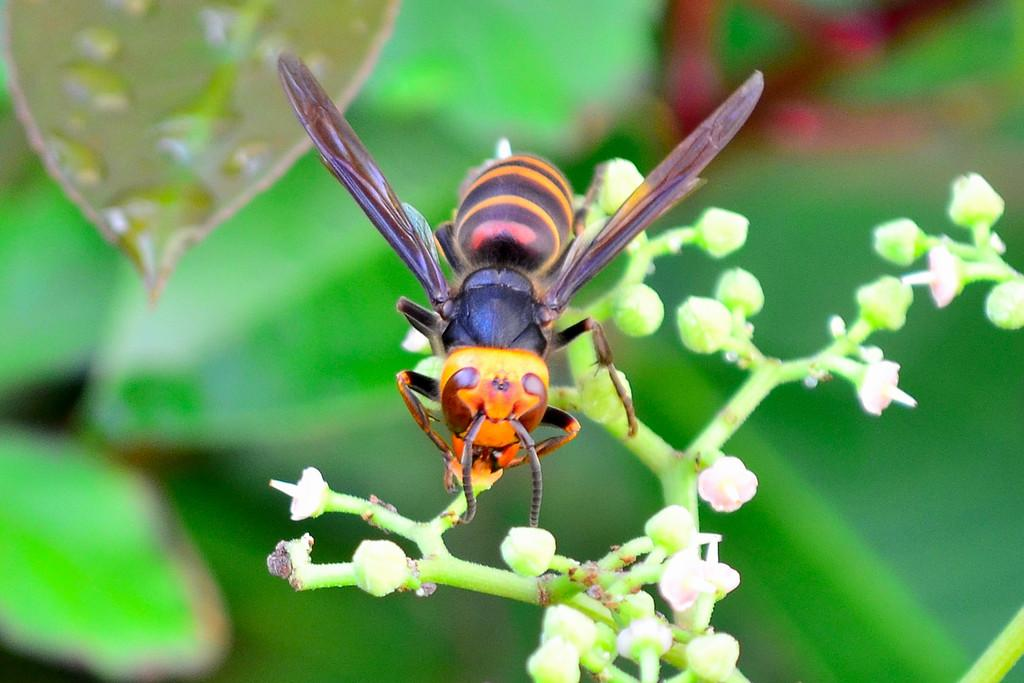What is present on the plant in the image? There is an insect on a plant in the image. What can be seen on the leaf in the image? There are water drops on a leaf in the image. How would you describe the background of the image? The background of the image is blurred. What type of oatmeal is being served on the bed in the image? There is no oatmeal or bed present in the image; it features an insect on a plant and water drops on a leaf. 